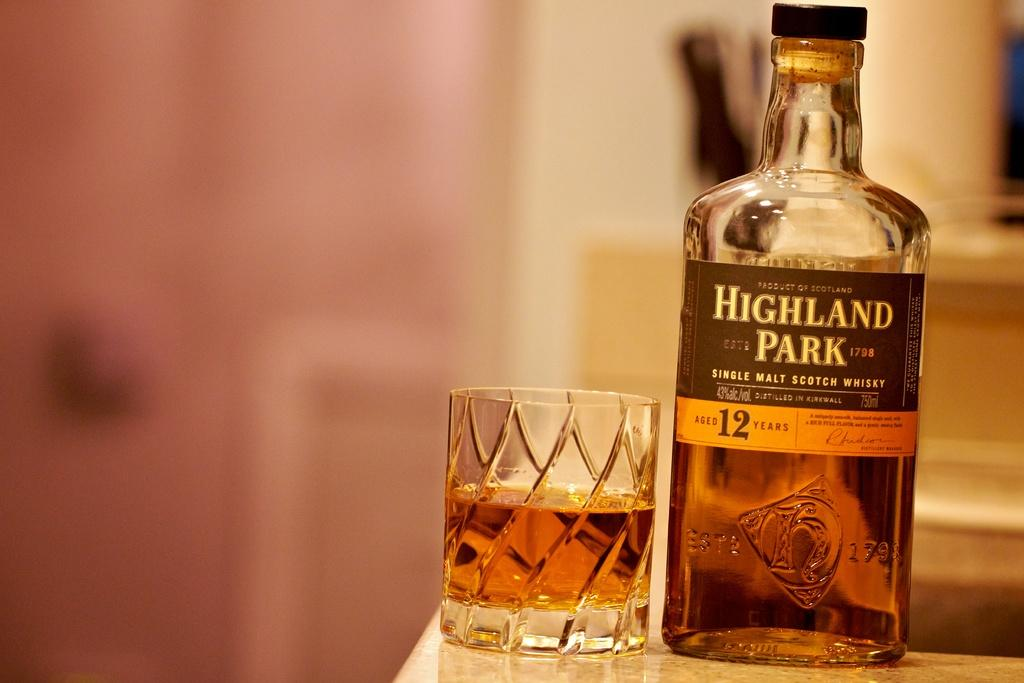<image>
Offer a succinct explanation of the picture presented. a bottle of highland park single malt scotch whiskey 